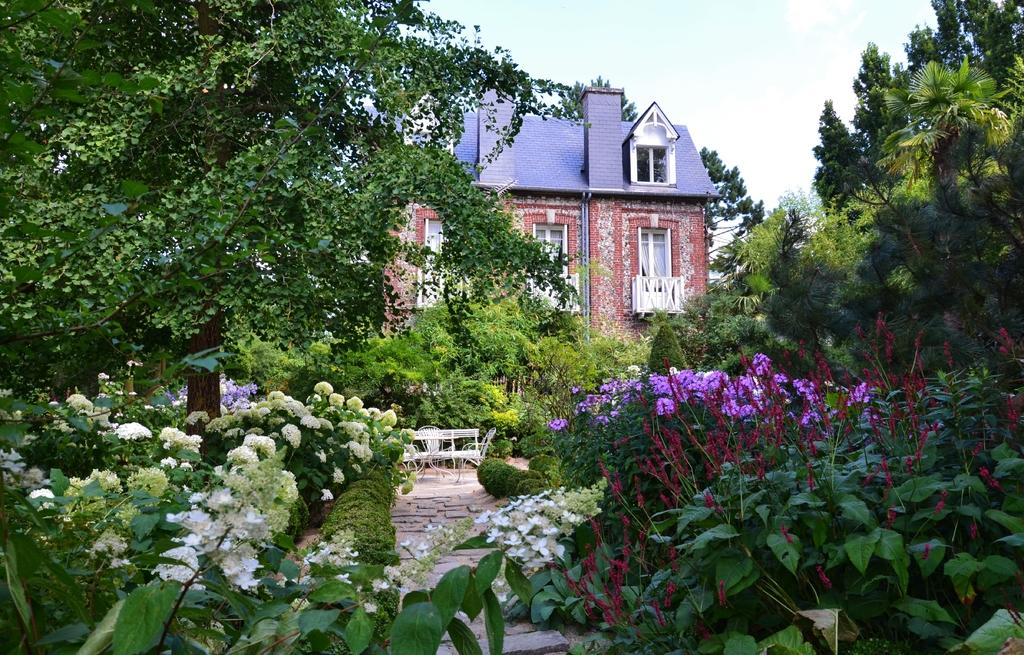What type of vegetation can be seen in the image? There are trees and plants with flowers in the image. What type of structure is present in the image? There is a building in the image. What type of seating is available in the image? There is a bench and chairs in the image. What is the condition of the sky in the image? The sky is cloudy in the image. What historical event is being commemorated by the police in the image? There are no police or historical events depicted in the image. What day of the week is it in the image? The day of the week is not mentioned or visible in the image. 